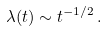<formula> <loc_0><loc_0><loc_500><loc_500>\lambda ( t ) \sim t ^ { - 1 / 2 } \, .</formula> 